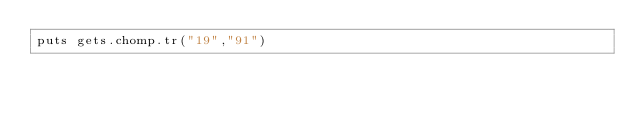<code> <loc_0><loc_0><loc_500><loc_500><_Ruby_>puts gets.chomp.tr("19","91")</code> 